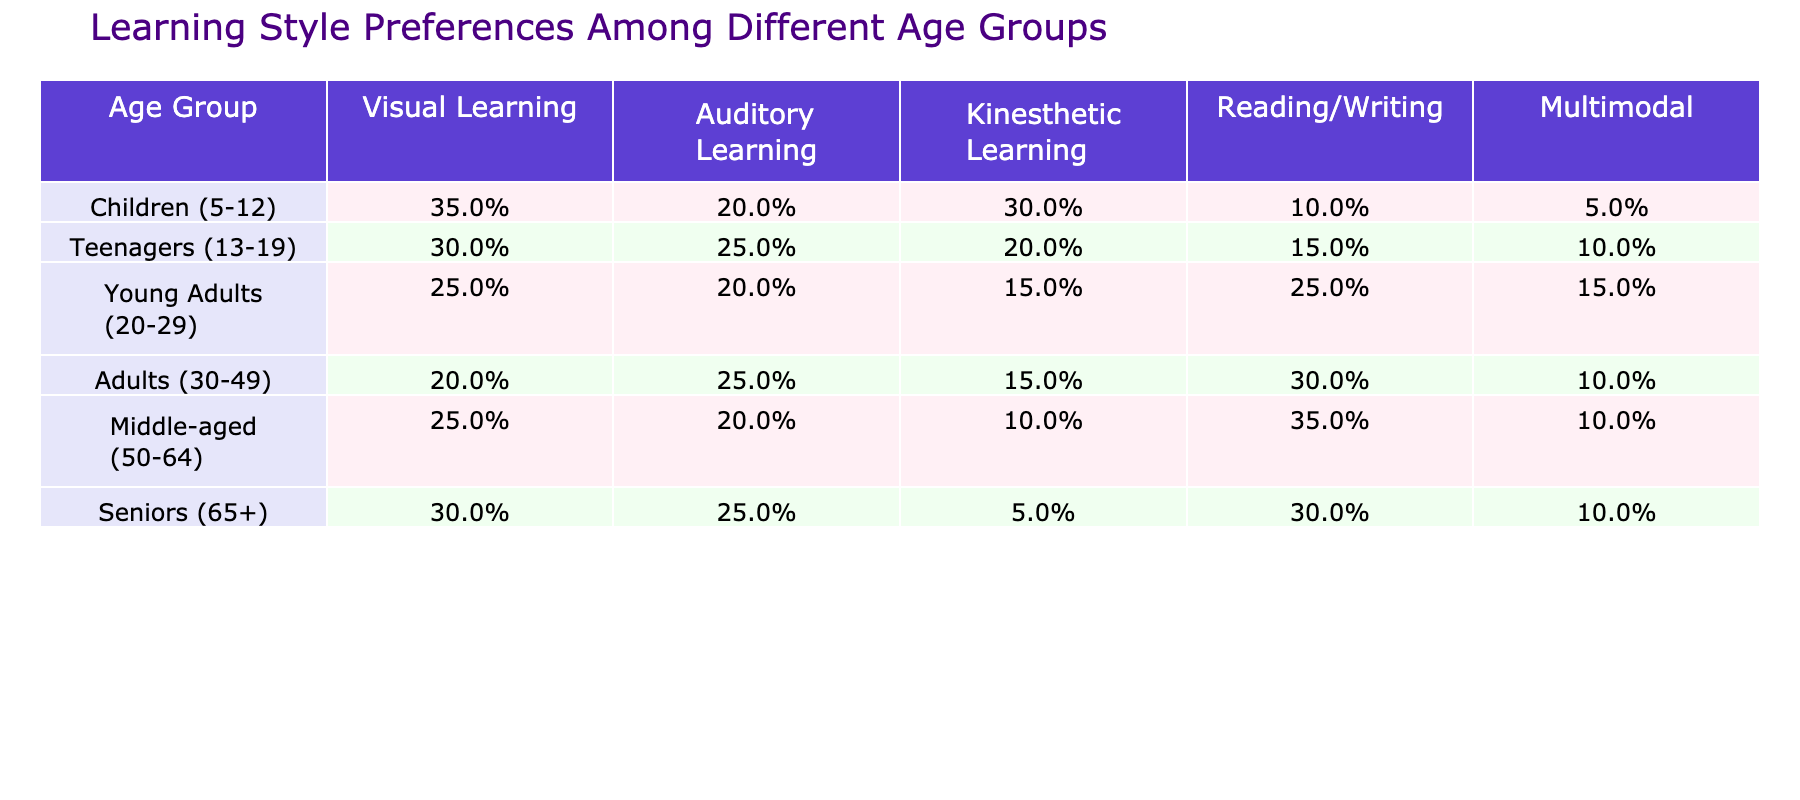What percentage of children prefer visual learning? The table indicates that 35% of children (ages 5-12) prefer visual learning, as shown in the corresponding row under the "Visual Learning" column.
Answer: 35% Which age group has the highest preference for reading/writing learning style? The highest value in the "Reading/Writing" column belongs to the "Middle-aged (50-64)" age group, with a preference of 35%.
Answer: Middle-aged (50-64) What is the overall preference for kinesthetic learning in all age groups combined? To determine this, we sum the kinesthetic learning percentages for all age groups: 30% + 20% + 15% + 15% + 10% + 5% = 95%. Then, divide by the number of age groups (6): 95% / 6 = 15.83%.
Answer: 15.83% Is the auditory learning preference for seniors higher than that of young adults? Looking at the table, seniors have 25% preference, while young adults have 20%, indicating seniors have a higher preference. This confirms the statement as true.
Answer: Yes What is the difference between the highest and lowest percentage of visual learning preference by age group? The highest visual learning preference is 35% (children), and the lowest is 20% (adults), leading to a difference of 35% - 20% = 15%.
Answer: 15% Which age group has the second-highest preference for auditory learning, and what is that percentage? By examining the "Auditory Learning" column, we see teenagers at 25% and adults with 25%, but since only one age group can be the second-highest, both are tied in this case. Therefore, they share the second-highest preference.
Answer: Teenagers and Adults, 25% If we compare the multimodal learning preferences among all groups, which age group shows the least interest? The "Multimodal" column shows that children have the lowest preference at 5% among all age groups when compared.
Answer: Children (5%) Which learning style does middle-aged individuals prefer the most when compared to other groups? The table indicates that middle-aged individuals have the highest preference for reading/writing at 35% compared to other styles in the same group.
Answer: Reading/Writing What is the average auditory learning preference across all age groups? The auditory learning preferences are: 20% (children), 25% (teenagers), 20% (young adults), 25% (adults), 20% (middle-aged), and 25% (seniors). This sums to 125%. The average is then calculated as 125% / 6 = 20.83%.
Answer: 20.83% Does the preference for kinesthetic learning decrease with age? When reviewing the values from children to seniors, we see the following percentages: 30%, 20%, 15%, 15%, 10%, and 5%. As the age progresses, the numbers show a clear decreasing trend, supporting the statement as true.
Answer: Yes 